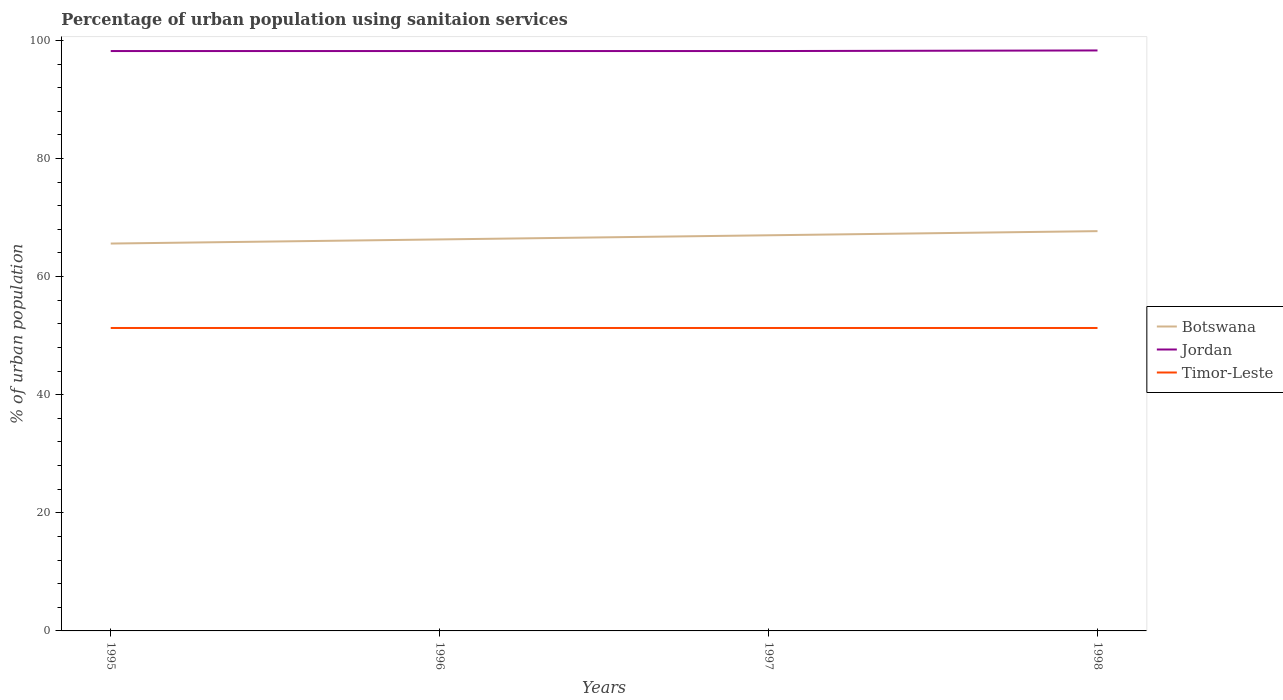How many different coloured lines are there?
Give a very brief answer. 3. Does the line corresponding to Botswana intersect with the line corresponding to Timor-Leste?
Offer a terse response. No. Is the number of lines equal to the number of legend labels?
Offer a terse response. Yes. Across all years, what is the maximum percentage of urban population using sanitaion services in Botswana?
Provide a short and direct response. 65.6. In which year was the percentage of urban population using sanitaion services in Jordan maximum?
Give a very brief answer. 1995. What is the total percentage of urban population using sanitaion services in Botswana in the graph?
Ensure brevity in your answer.  -0.7. What is the difference between the highest and the second highest percentage of urban population using sanitaion services in Jordan?
Provide a succinct answer. 0.1. What is the difference between the highest and the lowest percentage of urban population using sanitaion services in Timor-Leste?
Ensure brevity in your answer.  0. How many years are there in the graph?
Give a very brief answer. 4. What is the difference between two consecutive major ticks on the Y-axis?
Your response must be concise. 20. Are the values on the major ticks of Y-axis written in scientific E-notation?
Your answer should be compact. No. Does the graph contain grids?
Keep it short and to the point. No. How many legend labels are there?
Your response must be concise. 3. What is the title of the graph?
Give a very brief answer. Percentage of urban population using sanitaion services. Does "Equatorial Guinea" appear as one of the legend labels in the graph?
Provide a short and direct response. No. What is the label or title of the Y-axis?
Provide a short and direct response. % of urban population. What is the % of urban population in Botswana in 1995?
Keep it short and to the point. 65.6. What is the % of urban population in Jordan in 1995?
Ensure brevity in your answer.  98.2. What is the % of urban population of Timor-Leste in 1995?
Give a very brief answer. 51.3. What is the % of urban population of Botswana in 1996?
Offer a very short reply. 66.3. What is the % of urban population of Jordan in 1996?
Your answer should be very brief. 98.2. What is the % of urban population of Timor-Leste in 1996?
Provide a short and direct response. 51.3. What is the % of urban population of Jordan in 1997?
Make the answer very short. 98.2. What is the % of urban population in Timor-Leste in 1997?
Provide a succinct answer. 51.3. What is the % of urban population of Botswana in 1998?
Offer a very short reply. 67.7. What is the % of urban population of Jordan in 1998?
Your response must be concise. 98.3. What is the % of urban population in Timor-Leste in 1998?
Provide a succinct answer. 51.3. Across all years, what is the maximum % of urban population of Botswana?
Your answer should be compact. 67.7. Across all years, what is the maximum % of urban population of Jordan?
Keep it short and to the point. 98.3. Across all years, what is the maximum % of urban population in Timor-Leste?
Give a very brief answer. 51.3. Across all years, what is the minimum % of urban population in Botswana?
Provide a succinct answer. 65.6. Across all years, what is the minimum % of urban population of Jordan?
Make the answer very short. 98.2. Across all years, what is the minimum % of urban population in Timor-Leste?
Your answer should be very brief. 51.3. What is the total % of urban population in Botswana in the graph?
Your response must be concise. 266.6. What is the total % of urban population of Jordan in the graph?
Ensure brevity in your answer.  392.9. What is the total % of urban population in Timor-Leste in the graph?
Make the answer very short. 205.2. What is the difference between the % of urban population of Jordan in 1995 and that in 1996?
Ensure brevity in your answer.  0. What is the difference between the % of urban population of Timor-Leste in 1995 and that in 1996?
Provide a succinct answer. 0. What is the difference between the % of urban population of Botswana in 1995 and that in 1997?
Your answer should be compact. -1.4. What is the difference between the % of urban population in Timor-Leste in 1995 and that in 1997?
Provide a short and direct response. 0. What is the difference between the % of urban population in Botswana in 1995 and that in 1998?
Offer a terse response. -2.1. What is the difference between the % of urban population in Timor-Leste in 1995 and that in 1998?
Make the answer very short. 0. What is the difference between the % of urban population in Botswana in 1996 and that in 1997?
Provide a short and direct response. -0.7. What is the difference between the % of urban population of Botswana in 1996 and that in 1998?
Your answer should be compact. -1.4. What is the difference between the % of urban population in Jordan in 1996 and that in 1998?
Provide a short and direct response. -0.1. What is the difference between the % of urban population of Timor-Leste in 1997 and that in 1998?
Provide a short and direct response. 0. What is the difference between the % of urban population in Botswana in 1995 and the % of urban population in Jordan in 1996?
Give a very brief answer. -32.6. What is the difference between the % of urban population of Jordan in 1995 and the % of urban population of Timor-Leste in 1996?
Offer a very short reply. 46.9. What is the difference between the % of urban population of Botswana in 1995 and the % of urban population of Jordan in 1997?
Offer a very short reply. -32.6. What is the difference between the % of urban population in Jordan in 1995 and the % of urban population in Timor-Leste in 1997?
Keep it short and to the point. 46.9. What is the difference between the % of urban population of Botswana in 1995 and the % of urban population of Jordan in 1998?
Keep it short and to the point. -32.7. What is the difference between the % of urban population of Jordan in 1995 and the % of urban population of Timor-Leste in 1998?
Ensure brevity in your answer.  46.9. What is the difference between the % of urban population of Botswana in 1996 and the % of urban population of Jordan in 1997?
Make the answer very short. -31.9. What is the difference between the % of urban population in Jordan in 1996 and the % of urban population in Timor-Leste in 1997?
Your answer should be compact. 46.9. What is the difference between the % of urban population in Botswana in 1996 and the % of urban population in Jordan in 1998?
Provide a succinct answer. -32. What is the difference between the % of urban population of Botswana in 1996 and the % of urban population of Timor-Leste in 1998?
Offer a very short reply. 15. What is the difference between the % of urban population of Jordan in 1996 and the % of urban population of Timor-Leste in 1998?
Your response must be concise. 46.9. What is the difference between the % of urban population in Botswana in 1997 and the % of urban population in Jordan in 1998?
Offer a terse response. -31.3. What is the difference between the % of urban population in Jordan in 1997 and the % of urban population in Timor-Leste in 1998?
Offer a very short reply. 46.9. What is the average % of urban population in Botswana per year?
Keep it short and to the point. 66.65. What is the average % of urban population in Jordan per year?
Offer a very short reply. 98.22. What is the average % of urban population in Timor-Leste per year?
Your answer should be very brief. 51.3. In the year 1995, what is the difference between the % of urban population of Botswana and % of urban population of Jordan?
Offer a very short reply. -32.6. In the year 1995, what is the difference between the % of urban population in Jordan and % of urban population in Timor-Leste?
Your response must be concise. 46.9. In the year 1996, what is the difference between the % of urban population in Botswana and % of urban population in Jordan?
Your answer should be compact. -31.9. In the year 1996, what is the difference between the % of urban population of Botswana and % of urban population of Timor-Leste?
Offer a terse response. 15. In the year 1996, what is the difference between the % of urban population of Jordan and % of urban population of Timor-Leste?
Your response must be concise. 46.9. In the year 1997, what is the difference between the % of urban population of Botswana and % of urban population of Jordan?
Your answer should be very brief. -31.2. In the year 1997, what is the difference between the % of urban population in Botswana and % of urban population in Timor-Leste?
Provide a short and direct response. 15.7. In the year 1997, what is the difference between the % of urban population of Jordan and % of urban population of Timor-Leste?
Offer a very short reply. 46.9. In the year 1998, what is the difference between the % of urban population of Botswana and % of urban population of Jordan?
Keep it short and to the point. -30.6. In the year 1998, what is the difference between the % of urban population of Botswana and % of urban population of Timor-Leste?
Make the answer very short. 16.4. What is the ratio of the % of urban population in Botswana in 1995 to that in 1996?
Ensure brevity in your answer.  0.99. What is the ratio of the % of urban population in Jordan in 1995 to that in 1996?
Your answer should be very brief. 1. What is the ratio of the % of urban population in Timor-Leste in 1995 to that in 1996?
Offer a terse response. 1. What is the ratio of the % of urban population in Botswana in 1995 to that in 1997?
Keep it short and to the point. 0.98. What is the ratio of the % of urban population of Botswana in 1995 to that in 1998?
Make the answer very short. 0.97. What is the ratio of the % of urban population in Botswana in 1996 to that in 1997?
Your answer should be compact. 0.99. What is the ratio of the % of urban population in Jordan in 1996 to that in 1997?
Give a very brief answer. 1. What is the ratio of the % of urban population in Botswana in 1996 to that in 1998?
Provide a succinct answer. 0.98. What is the ratio of the % of urban population of Timor-Leste in 1997 to that in 1998?
Your response must be concise. 1. What is the difference between the highest and the second highest % of urban population of Botswana?
Keep it short and to the point. 0.7. What is the difference between the highest and the second highest % of urban population of Timor-Leste?
Your answer should be compact. 0. What is the difference between the highest and the lowest % of urban population of Botswana?
Ensure brevity in your answer.  2.1. 